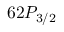Convert formula to latex. <formula><loc_0><loc_0><loc_500><loc_500>6 2 P _ { 3 / 2 }</formula> 